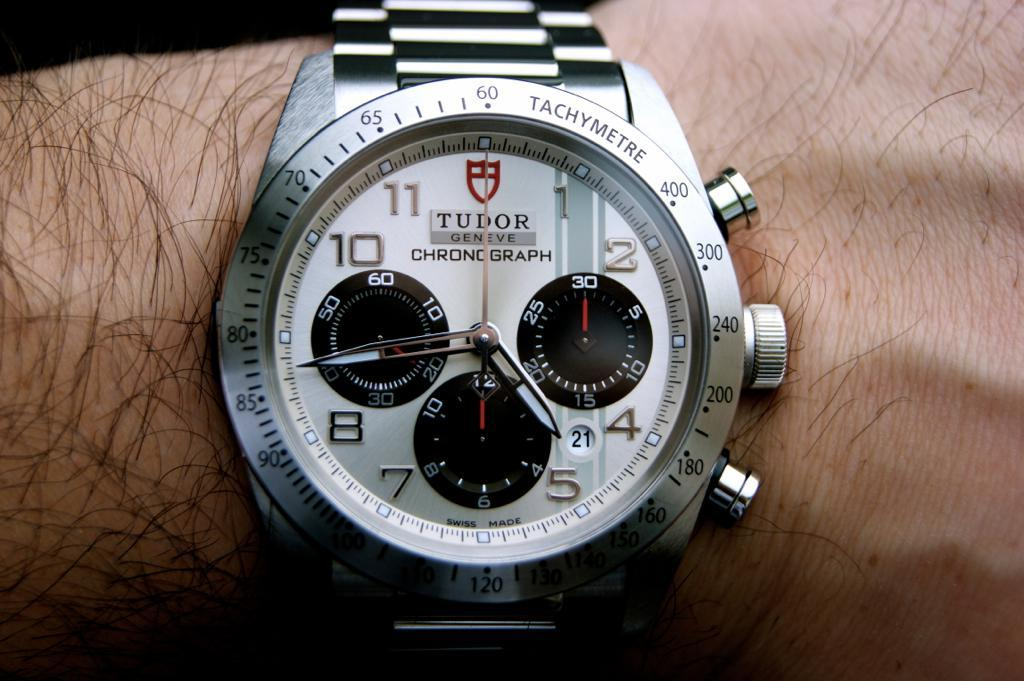<image>
Describe the image concisely. A man is wearing a silver watch that says Tudor Geneve. 